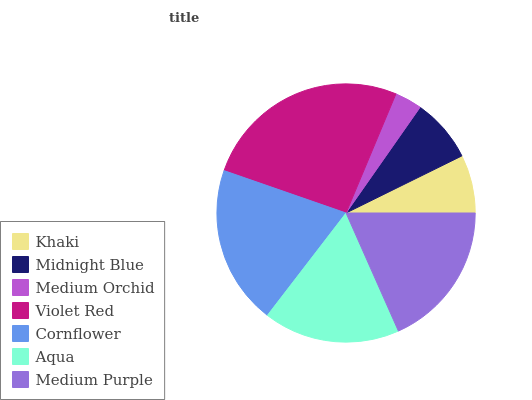Is Medium Orchid the minimum?
Answer yes or no. Yes. Is Violet Red the maximum?
Answer yes or no. Yes. Is Midnight Blue the minimum?
Answer yes or no. No. Is Midnight Blue the maximum?
Answer yes or no. No. Is Midnight Blue greater than Khaki?
Answer yes or no. Yes. Is Khaki less than Midnight Blue?
Answer yes or no. Yes. Is Khaki greater than Midnight Blue?
Answer yes or no. No. Is Midnight Blue less than Khaki?
Answer yes or no. No. Is Aqua the high median?
Answer yes or no. Yes. Is Aqua the low median?
Answer yes or no. Yes. Is Midnight Blue the high median?
Answer yes or no. No. Is Cornflower the low median?
Answer yes or no. No. 